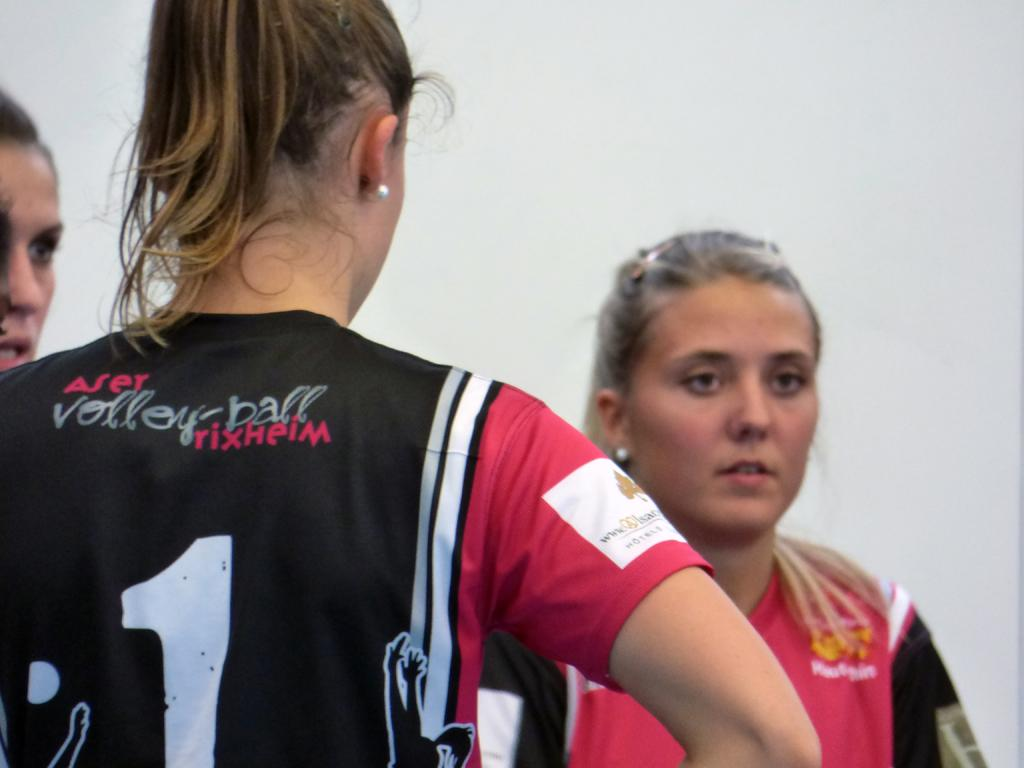Provide a one-sentence caption for the provided image. a volleyball player with a jersey that says ' aser volleyball rixheim'. 